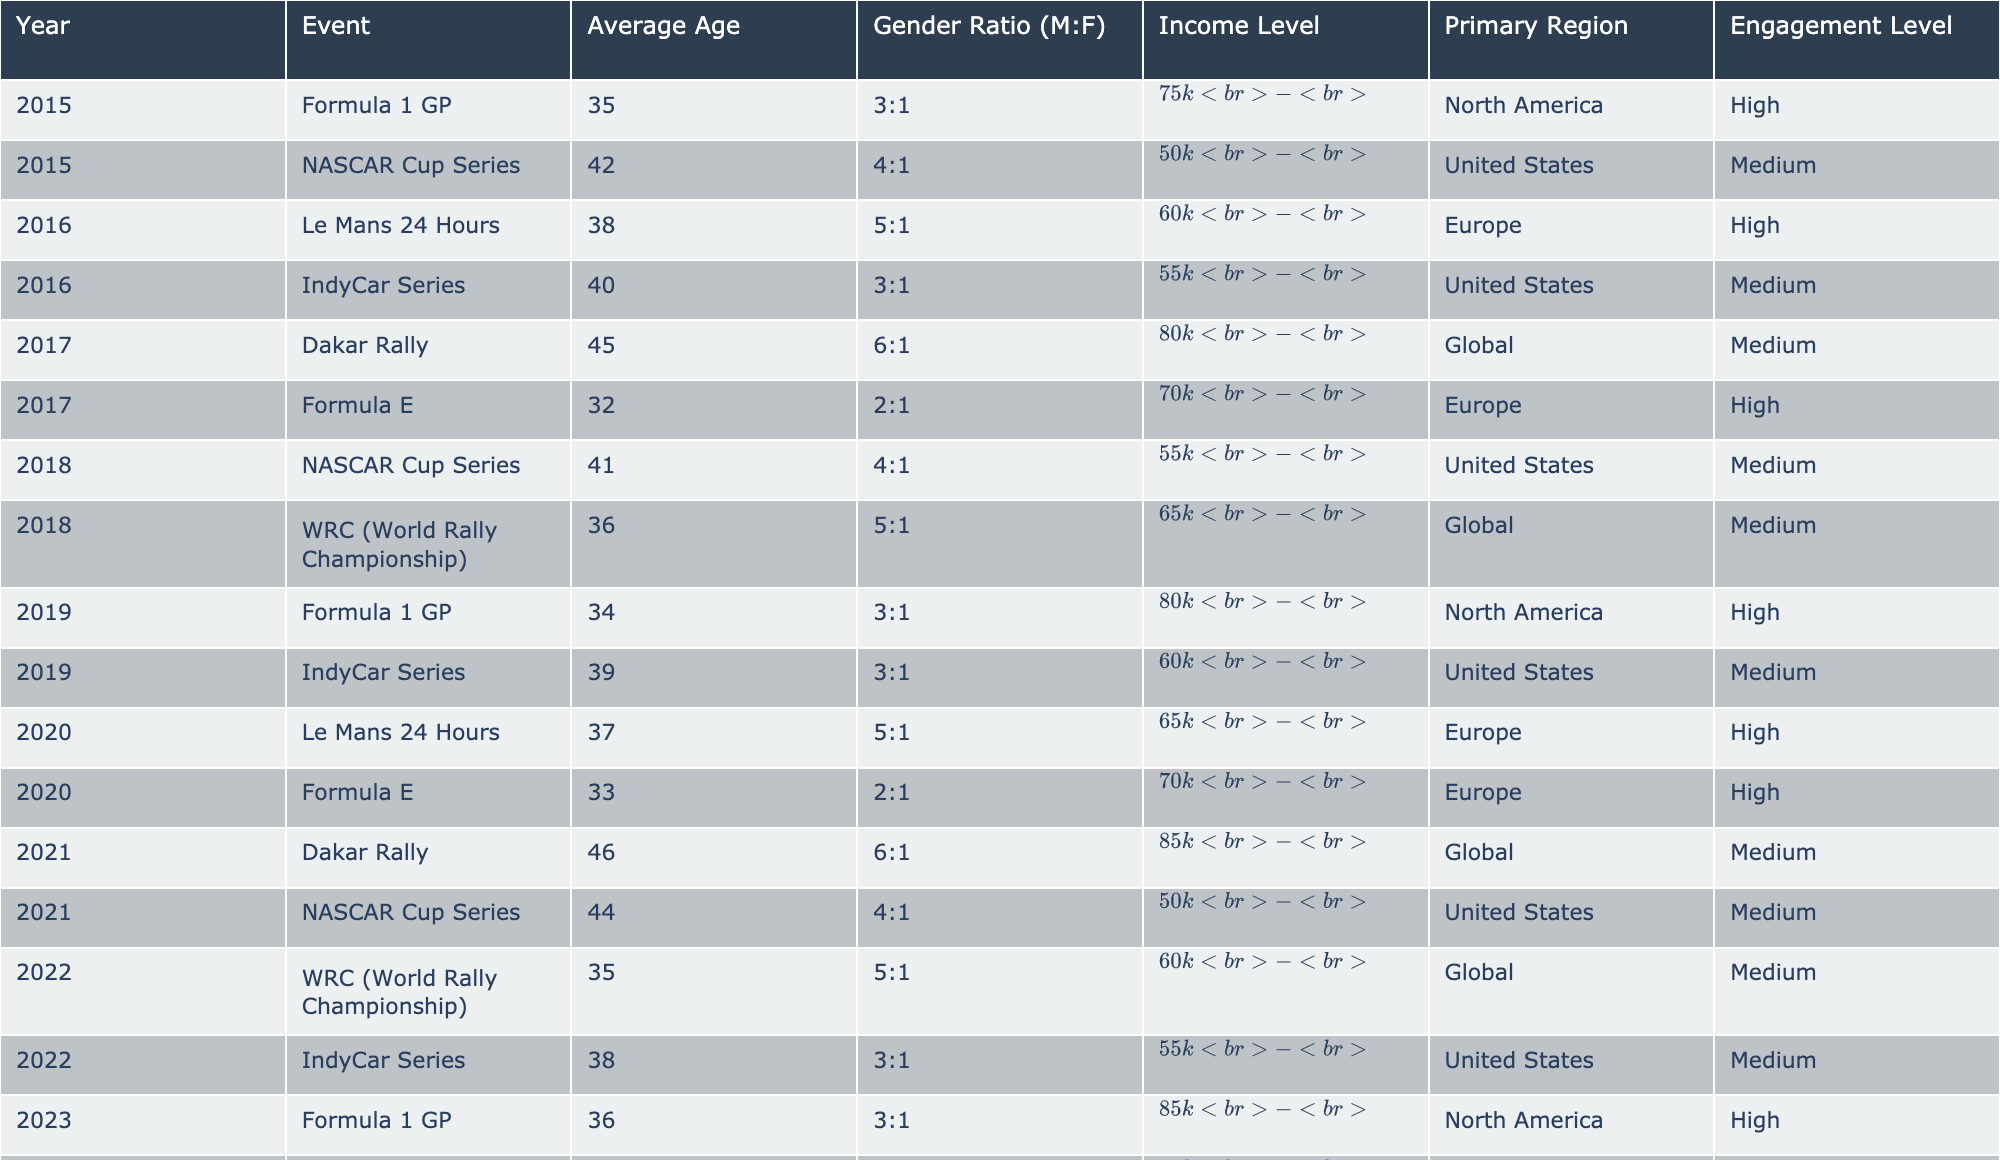What is the average age of the audience for the Dakar Rally in 2021? The table shows that the average age of the audience for the Dakar Rally in 2021 is 46 years.
Answer: 46 Which event had the highest gender ratio of males to females in 2017? From the table, the Dakar Rally in 2017 has the highest gender ratio, which is 6:1.
Answer: 6:1 Is the average income level for the IndyCar Series in 2018 lower than the average income level for the same series in 2022? The average income level for the IndyCar Series in 2018 is "$55k - $80k," while in 2022 it is "$55k - $80k" as well, making them equal.
Answer: No What is the engagement level for the Formula E event in 2020 compared to the Formula E event in 2017? Both Formula E events in 2020 and 2017 have a high engagement level, indicating strong audience interest in both years.
Answer: Same (High) Which event had the highest average age among all events from 2015 to 2023? The Dakar Rally in 2021 has the highest average age of 46 years, making it the oldest audience demographic among the events listed.
Answer: 46 What is the average income level of the audience for NASCAR Cup Series events from 2015 to 2022? The income levels are "$50k - $75k" for 2015, "$55k - $85k" for 2018, and "$50k - $75k" for 2021, averaging out will put it in the range of approximately "$52.5k - $75k".
Answer: ~$52.5k - $75k Has the average age of the audience for Formula 1 GP increased from 2015 to 2023? The average age went from 35 in 2015 to 36 in 2023, indicating a slight increase over the years.
Answer: Yes How many major events had a medium engagement level in 2019? The table indicates that there are two events in 2019 with a medium engagement level: the IndyCar Series and Formula 1 GP.
Answer: 2 What is the difference in average age of the audience between the Dakar Rally in 2021 and the Le Mans 24 Hours in 2020? The average age for the Dakar Rally in 2021 is 46, while for Le Mans 24 Hours in 2020 it is 37. The difference is 46 - 37 = 9 years.
Answer: 9 years Is the average age of the audience for the WRC events in 2018 and 2022 the same? The average age for the WRC in 2018 is 36, while in 2022 it is 35, so they are not the same.
Answer: No 